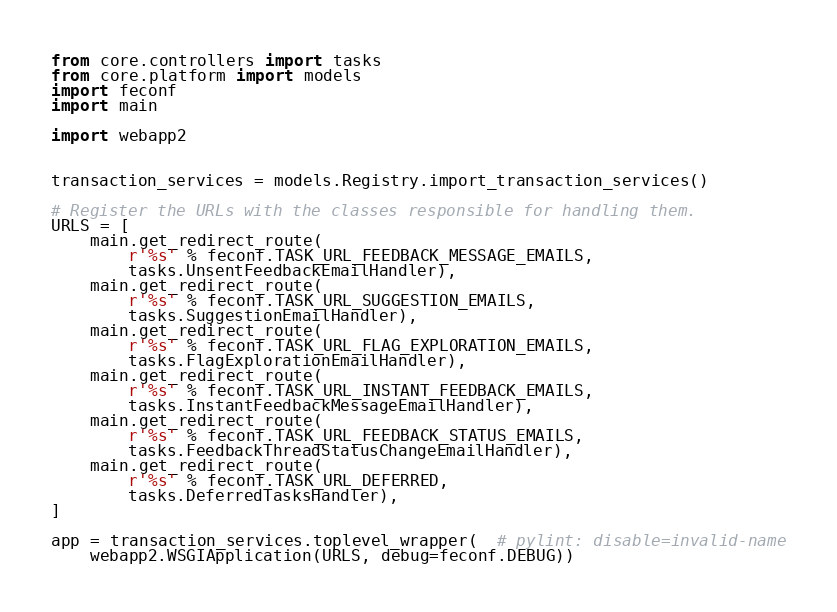<code> <loc_0><loc_0><loc_500><loc_500><_Python_>
from core.controllers import tasks
from core.platform import models
import feconf
import main

import webapp2


transaction_services = models.Registry.import_transaction_services()

# Register the URLs with the classes responsible for handling them.
URLS = [
    main.get_redirect_route(
        r'%s' % feconf.TASK_URL_FEEDBACK_MESSAGE_EMAILS,
        tasks.UnsentFeedbackEmailHandler),
    main.get_redirect_route(
        r'%s' % feconf.TASK_URL_SUGGESTION_EMAILS,
        tasks.SuggestionEmailHandler),
    main.get_redirect_route(
        r'%s' % feconf.TASK_URL_FLAG_EXPLORATION_EMAILS,
        tasks.FlagExplorationEmailHandler),
    main.get_redirect_route(
        r'%s' % feconf.TASK_URL_INSTANT_FEEDBACK_EMAILS,
        tasks.InstantFeedbackMessageEmailHandler),
    main.get_redirect_route(
        r'%s' % feconf.TASK_URL_FEEDBACK_STATUS_EMAILS,
        tasks.FeedbackThreadStatusChangeEmailHandler),
    main.get_redirect_route(
        r'%s' % feconf.TASK_URL_DEFERRED,
        tasks.DeferredTasksHandler),
]

app = transaction_services.toplevel_wrapper(  # pylint: disable=invalid-name
    webapp2.WSGIApplication(URLS, debug=feconf.DEBUG))
</code> 